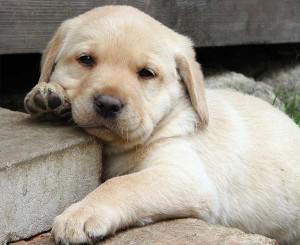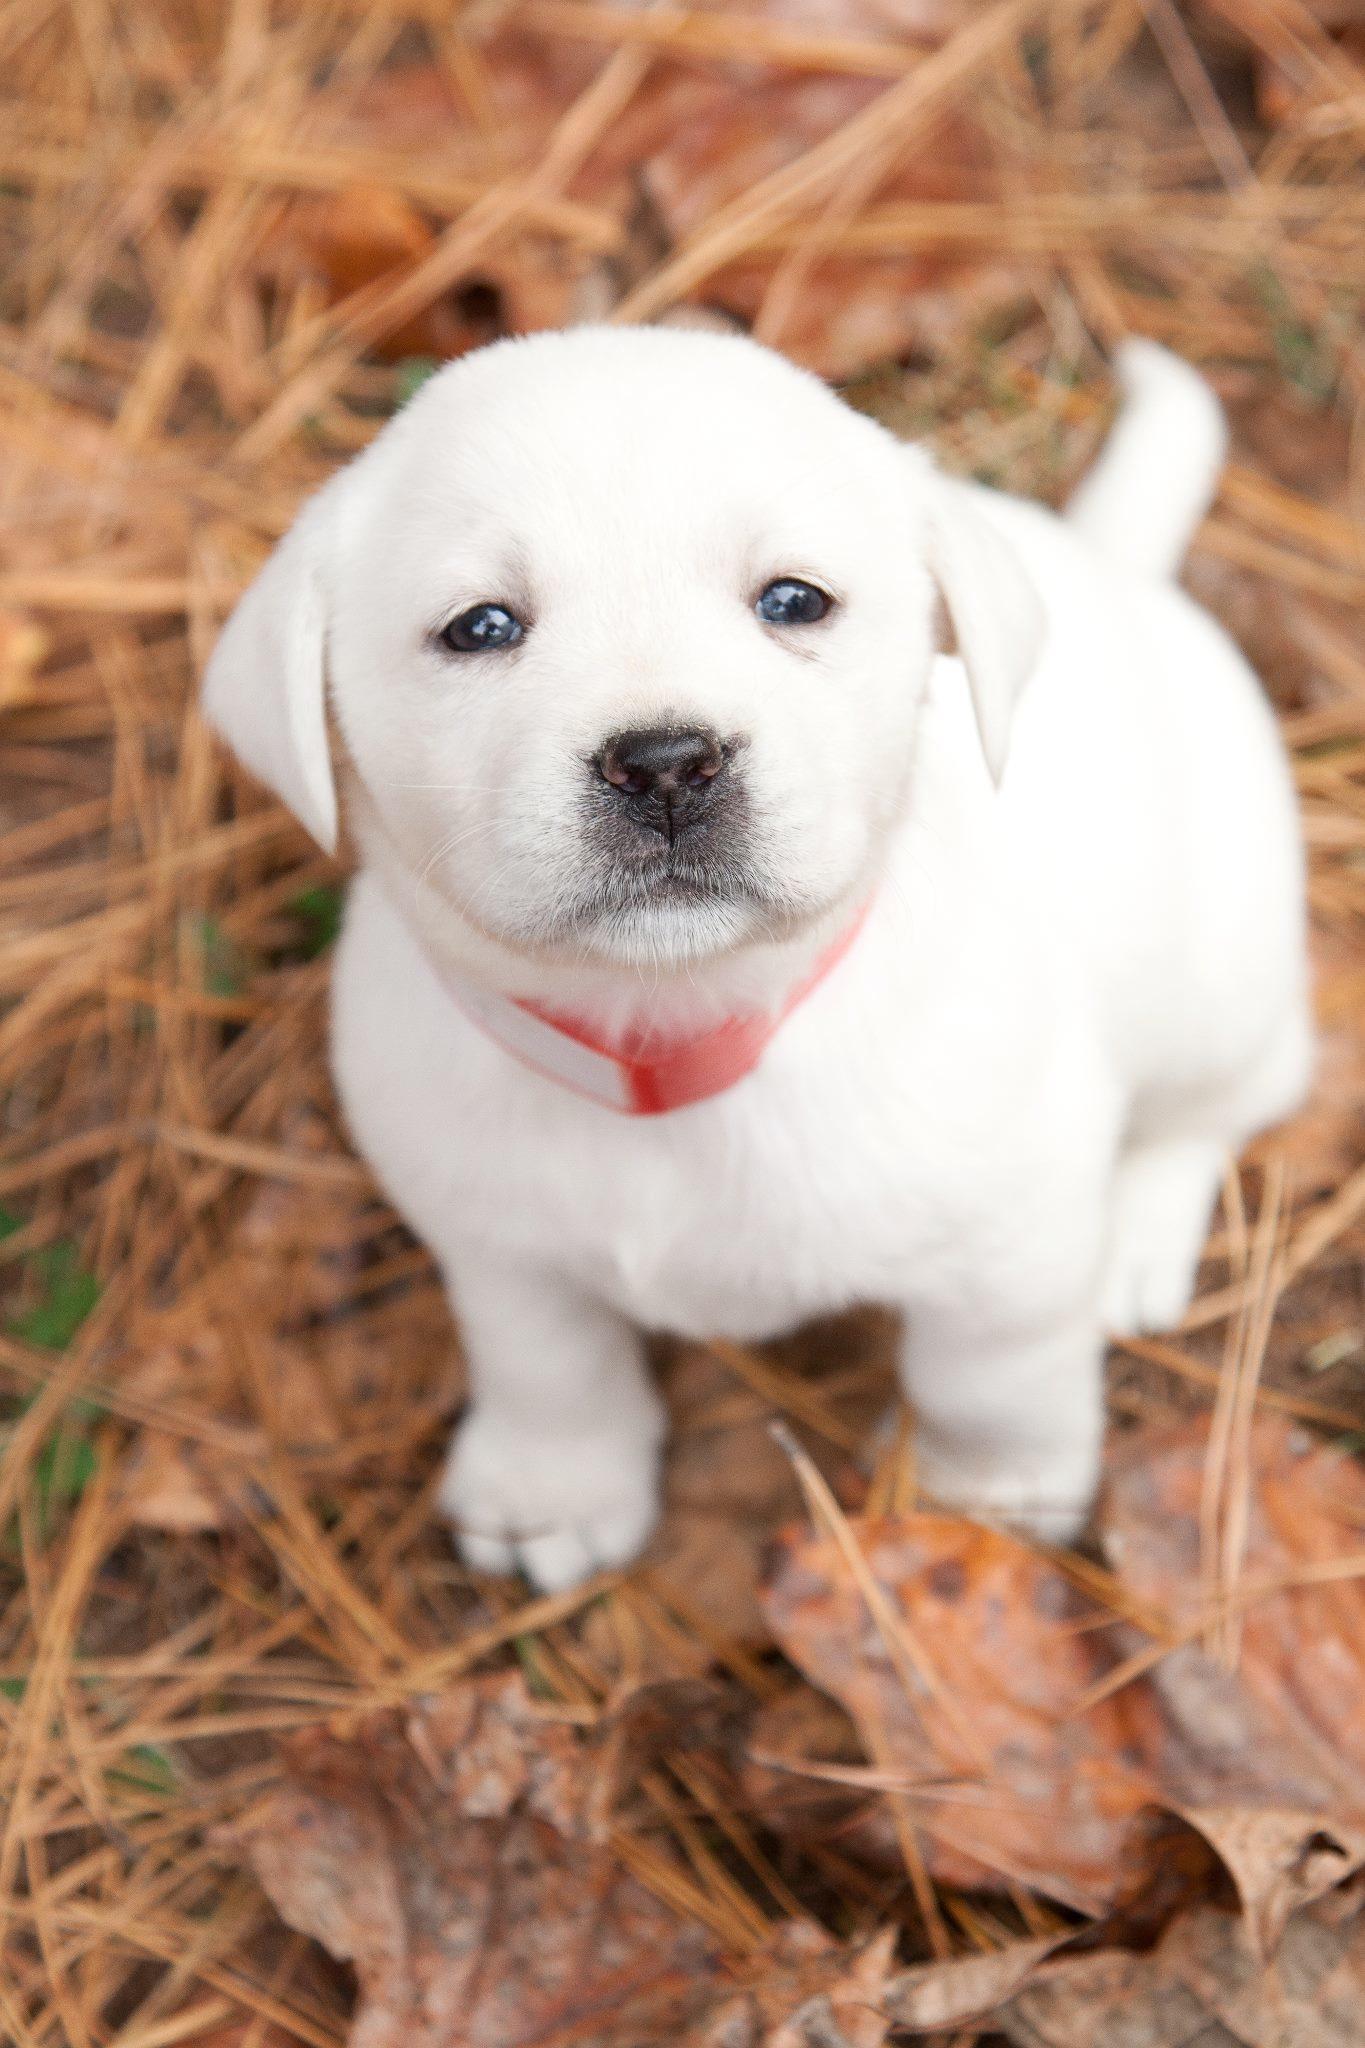The first image is the image on the left, the second image is the image on the right. For the images shown, is this caption "Each image contains one dog, and every dog is a """"blond"""" puppy." true? Answer yes or no. Yes. The first image is the image on the left, the second image is the image on the right. Analyze the images presented: Is the assertion "The left image contains one dog laying on wooden flooring." valid? Answer yes or no. No. 